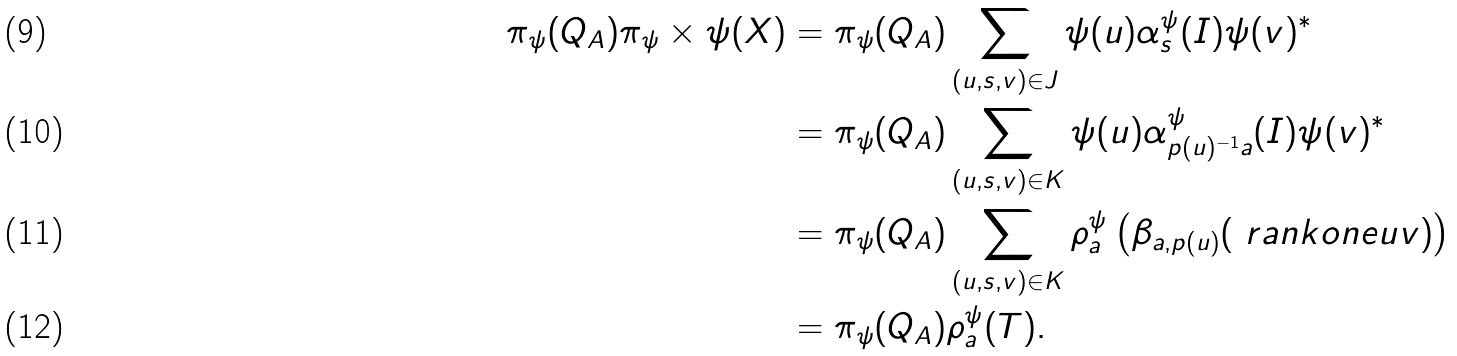Convert formula to latex. <formula><loc_0><loc_0><loc_500><loc_500>\pi _ { \psi } ( Q _ { A } ) \pi _ { \psi } \times \psi ( X ) & = \pi _ { \psi } ( Q _ { A } ) \sum _ { ( u , s , v ) \in J } \psi ( u ) \alpha ^ { \psi } _ { s } ( I ) \psi ( v ) ^ { * } \\ & = \pi _ { \psi } ( Q _ { A } ) \sum _ { ( u , s , v ) \in K } \psi ( u ) \alpha ^ { \psi } _ { p ( u ) ^ { - 1 } a } ( I ) \psi ( v ) ^ { * } \\ & = \pi _ { \psi } ( Q _ { A } ) \sum _ { ( u , s , v ) \in K } \rho ^ { \psi } _ { a } \left ( \beta _ { a , p ( u ) } ( \ r a n k o n e u v ) \right ) \\ & = \pi _ { \psi } ( Q _ { A } ) \rho ^ { \psi } _ { a } ( T ) .</formula> 